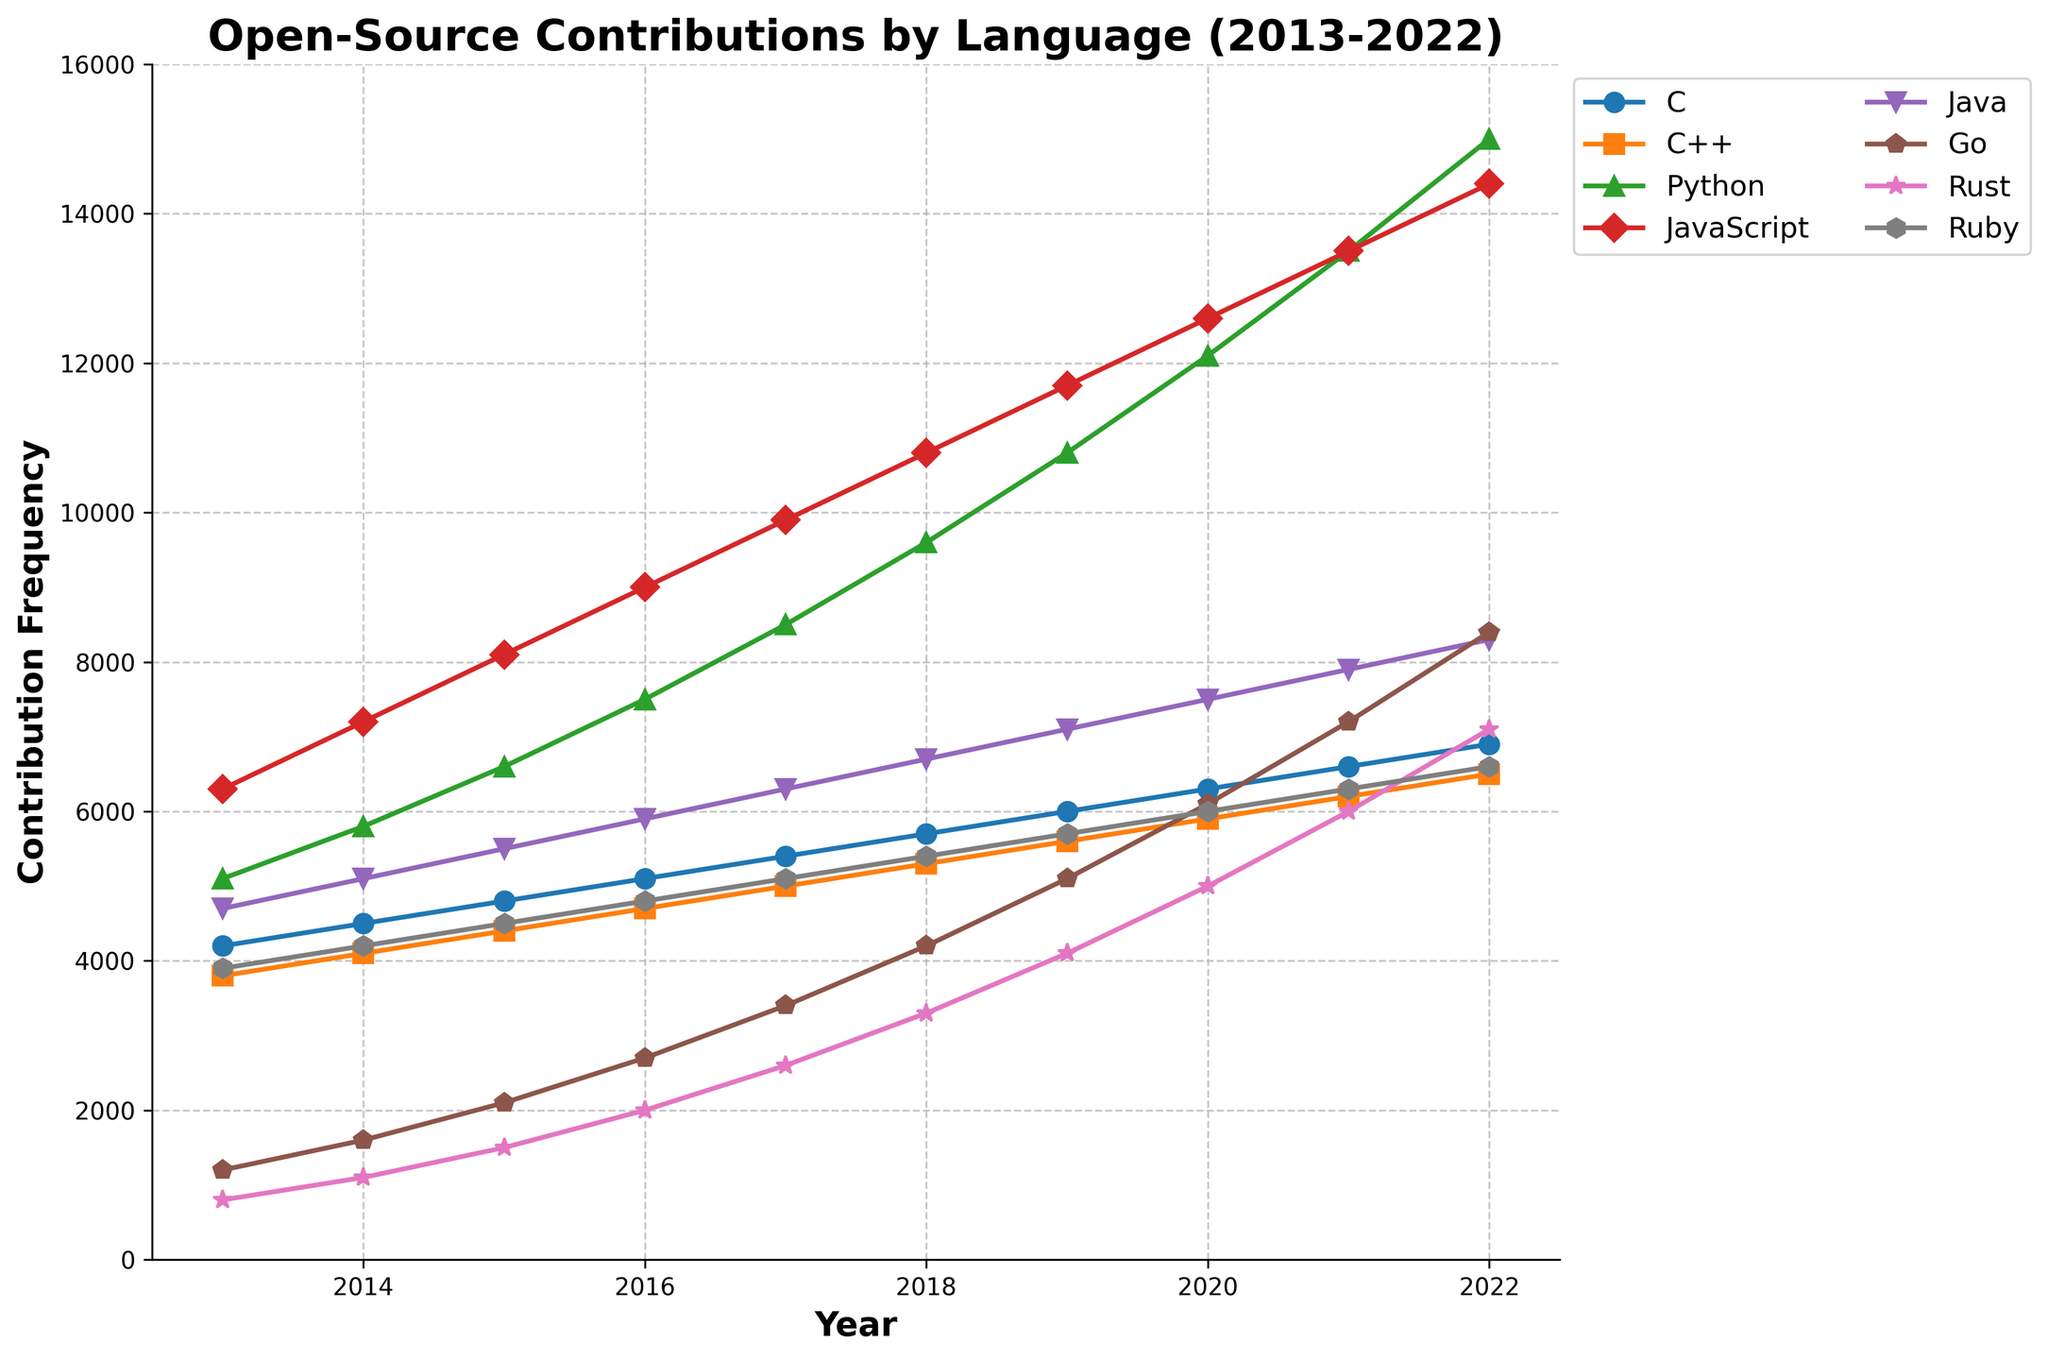Which language had the highest contribution frequency in 2022? First, locate the year 2022 on the x-axis. Then, look for the highest data point among all the lines. The highest point corresponds to Python.
Answer: Python How did the contribution frequency of Rust change from 2013 to 2022? Find Rust’s data points for the years 2013 and 2022. In 2013, it was 800, and in 2022, it was 7100. Calculate the difference: 7100 - 800 = 6300. So, Rust’s contribution frequency increased by 6300.
Answer: Increased by 6300 Which language showed the most consistent growth in contribution frequency over the decade? Examine the lines’ slopes from 2013 to 2022. The languages with the most uniform upward slopes indicate consistent growth. Python displays a steady and consistent increase.
Answer: Python What is the average contribution frequency of C++ over the decade? Sum the contribution frequencies for C++ from 2013 to 2022 (3800, 4100, 4400, 4700, 5000, 5300, 5600, 5900, 6200, and 6500). Then, divide by the number of years (10). (3800 + 4100 + 4400 + 4700 + 5000 + 5300 + 5600 + 5900 + 6200 + 6500) / 10 = 51500 / 10 = 5150.
Answer: 5150 Which language had the steepest increase in contribution frequency between any two consecutive years? Look for the steepest segment between any two consecutive years among all the lines. Identify the steepest change by comparing segment heights. The segment from 2019 to 2020 for Python shows the steepest increase (12100 - 10800 = 1300).
Answer: Python (2019-2020) Between 2017 and 2022, which language had the highest increment in contribution frequency? Identify each language’s contribution frequency for 2017 and 2022. Calculate the difference for each language, then compare. For Python, the increment is 15000 - 8500 = 6500, which is the highest among all languages.
Answer: Python By how much did the contribution frequency of Go increase from 2013 to 2022? Find Go’s data points for 2013 and 2022. In 2013, it was 1200, and in 2022, it was 8400. Calculate the difference: 8400 - 1200 = 7200.
Answer: 7200 When did JavaScript surpass Java in contribution frequency? Track the points where the JavaScript (red) and Java (purple) lines cross. In 2014, JavaScript (7200) surpasses Java(5100).
Answer: 2014 